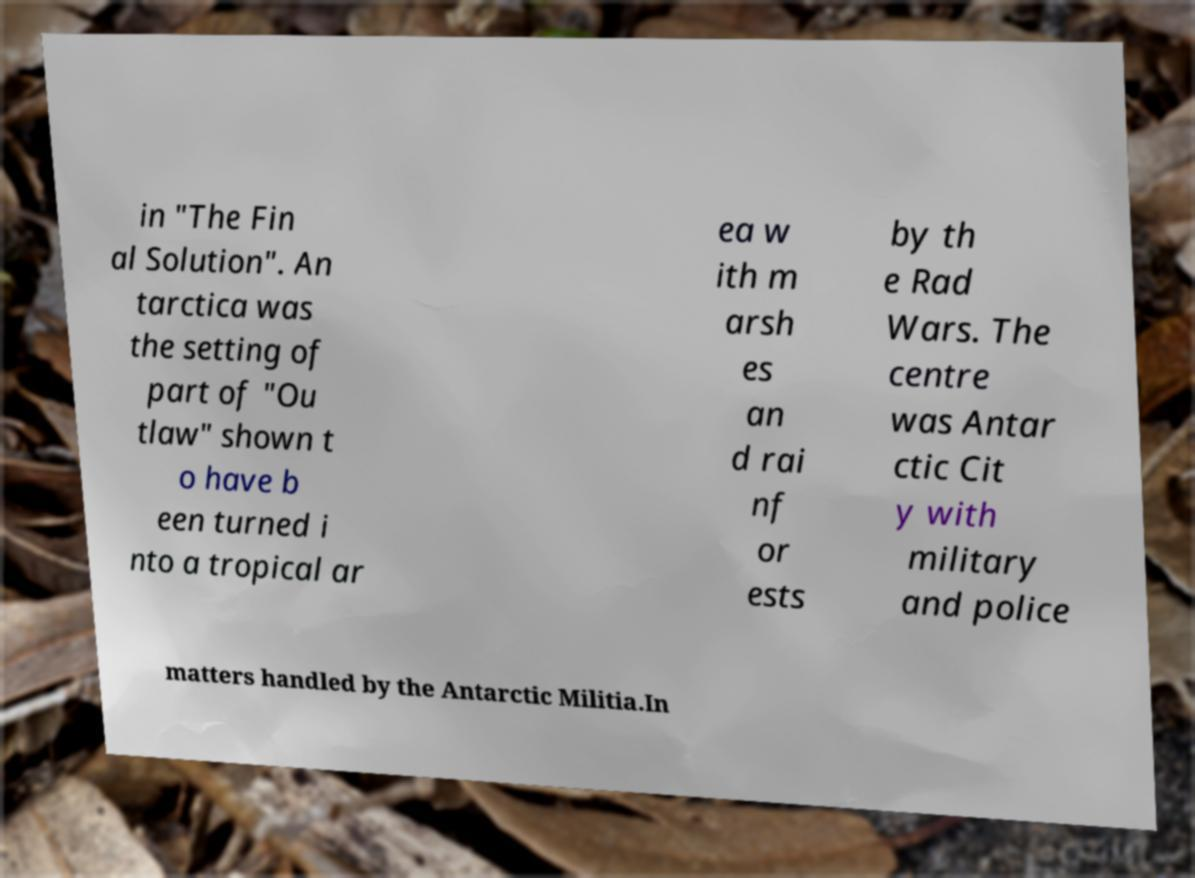Please identify and transcribe the text found in this image. in "The Fin al Solution". An tarctica was the setting of part of "Ou tlaw" shown t o have b een turned i nto a tropical ar ea w ith m arsh es an d rai nf or ests by th e Rad Wars. The centre was Antar ctic Cit y with military and police matters handled by the Antarctic Militia.In 